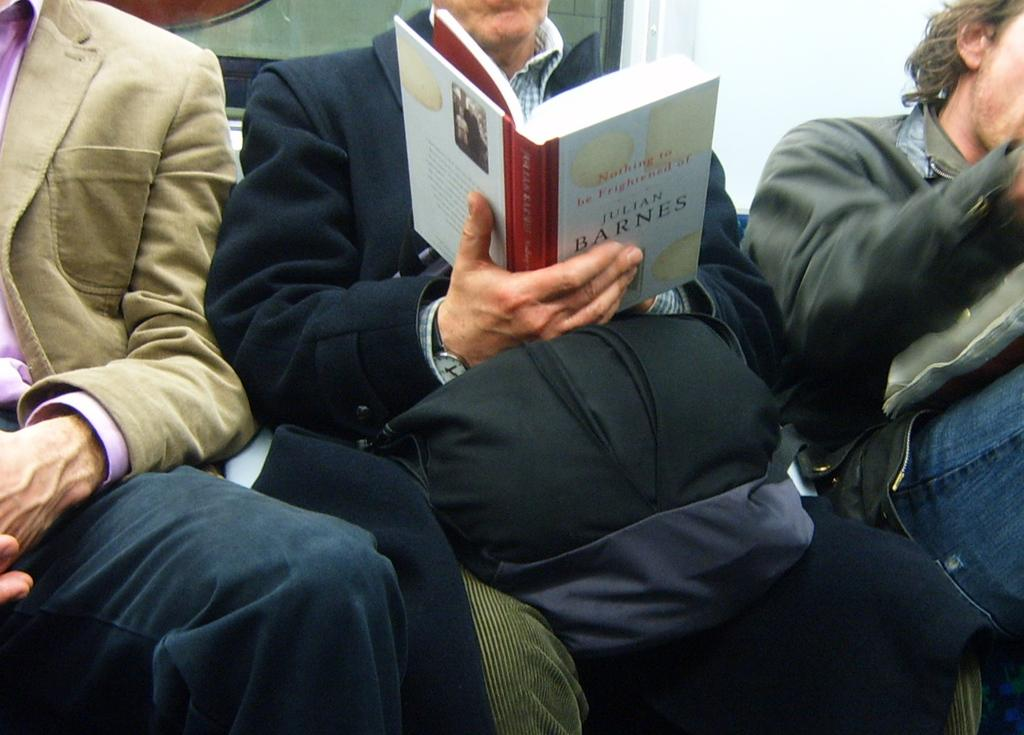<image>
Relay a brief, clear account of the picture shown. A man reads a book written by Julian Barnes. 